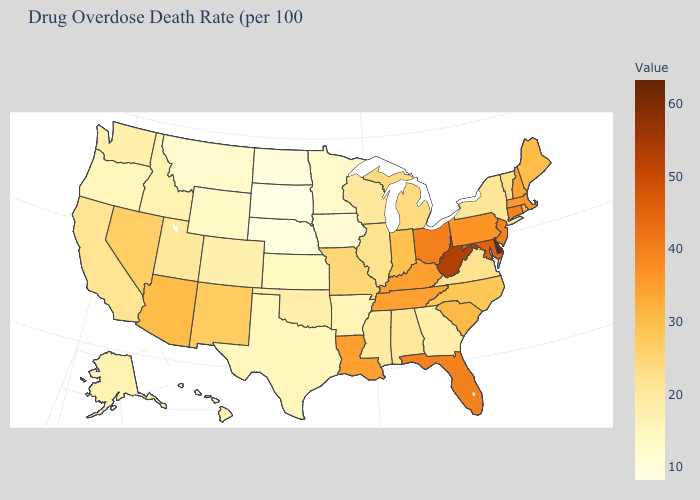Among the states that border New York , which have the highest value?
Be succinct. New Jersey. Among the states that border Georgia , which have the highest value?
Keep it brief. Florida. Is the legend a continuous bar?
Answer briefly. Yes. Among the states that border Nebraska , does South Dakota have the lowest value?
Be succinct. Yes. Does the map have missing data?
Keep it brief. No. Among the states that border Kentucky , does West Virginia have the highest value?
Be succinct. Yes. Does Florida have the highest value in the South?
Write a very short answer. No. Does Delaware have the highest value in the USA?
Keep it brief. Yes. Does Wisconsin have a lower value than Maine?
Keep it brief. Yes. 